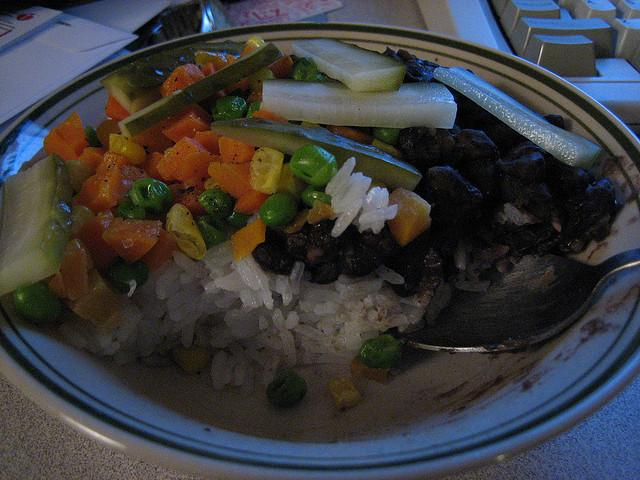What is available on this meal among the following ingredients options? rice 